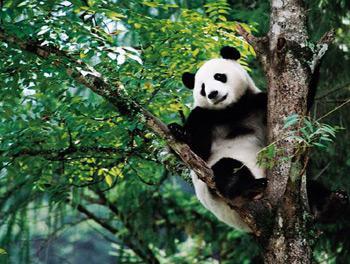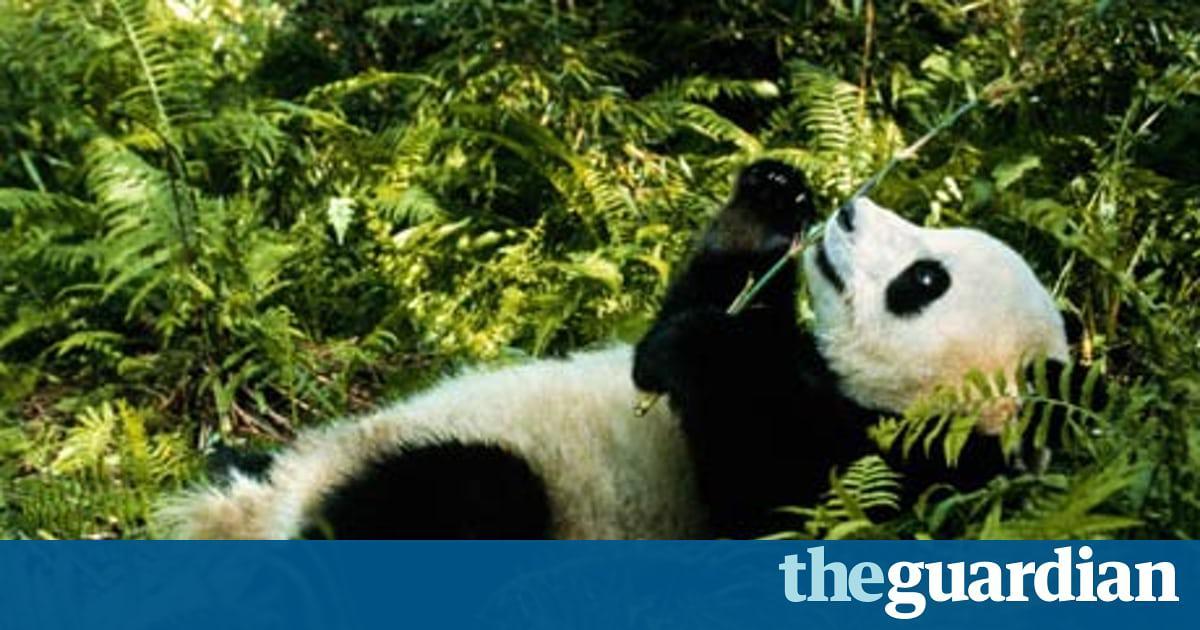The first image is the image on the left, the second image is the image on the right. Given the left and right images, does the statement "Each image shows one panda perched off the ground in something tree-like, and at least one image shows a panda with front paws around a forking tree limb." hold true? Answer yes or no. No. The first image is the image on the left, the second image is the image on the right. Considering the images on both sides, is "Each image features a panda in a tree" valid? Answer yes or no. No. 